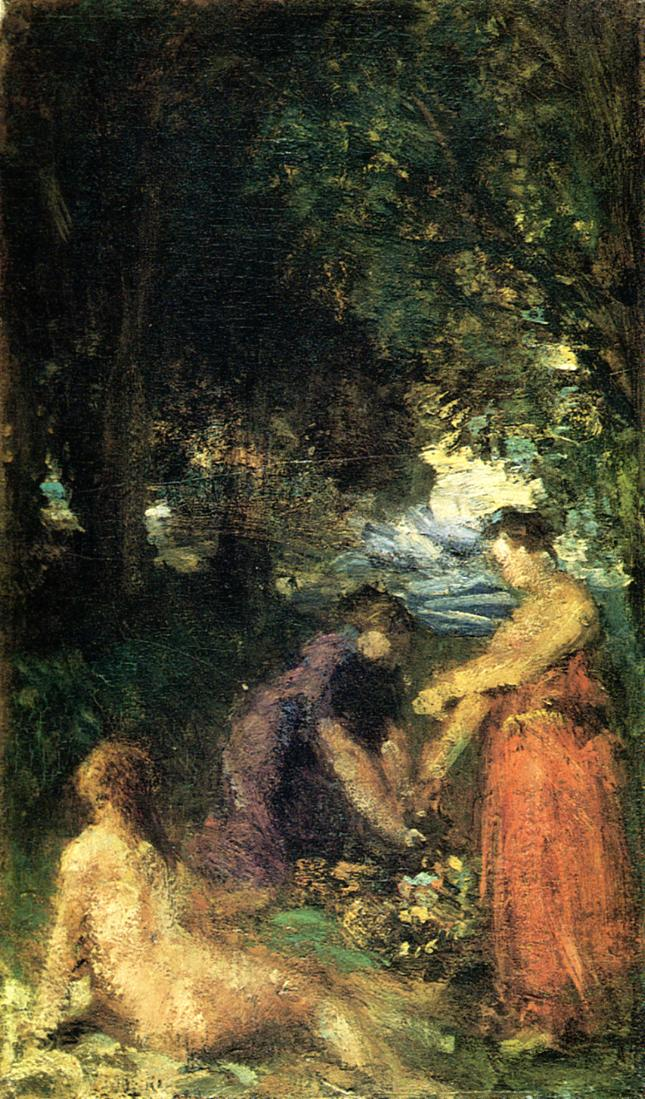What do you think is going on in this snapshot? The image appears to be an impressionist painting that depicts a serene scene of a group of people gathered in a tranquil forest setting. This impression is created through the use of a rich, earthy palette dominated by dark greens and browns which convey depth and a sense of natural surroundings. The artist employs the hallmark loose brushstrokes of the impressionist style, capturing movement and vibrancy. Amid the dense foliage, a glimpse of clear blue sky peeks through, adding a contrasting brightness to the composition.

The figures are portrayed with different levels of detail. Those in the foreground are more distinctly rendered, their poses and clothing more recognizable, while those in the background merge more seamlessly into the environment, indicated by softer, less defined shapes. This contrast draws the viewer's focus and enhances the overall depth of the scene.

Given the style, the painting is likely from the Impressionist era, spanning the late 19th to early 20th centuries. The focus on capturing fleeting moments and the beauty of natural light, characteristic of this art movement, is evident. The painting invites viewers to immerse themselves in the peaceful and communal atmosphere of a shared moment in nature, appreciating the harmony between people and the landscape. 